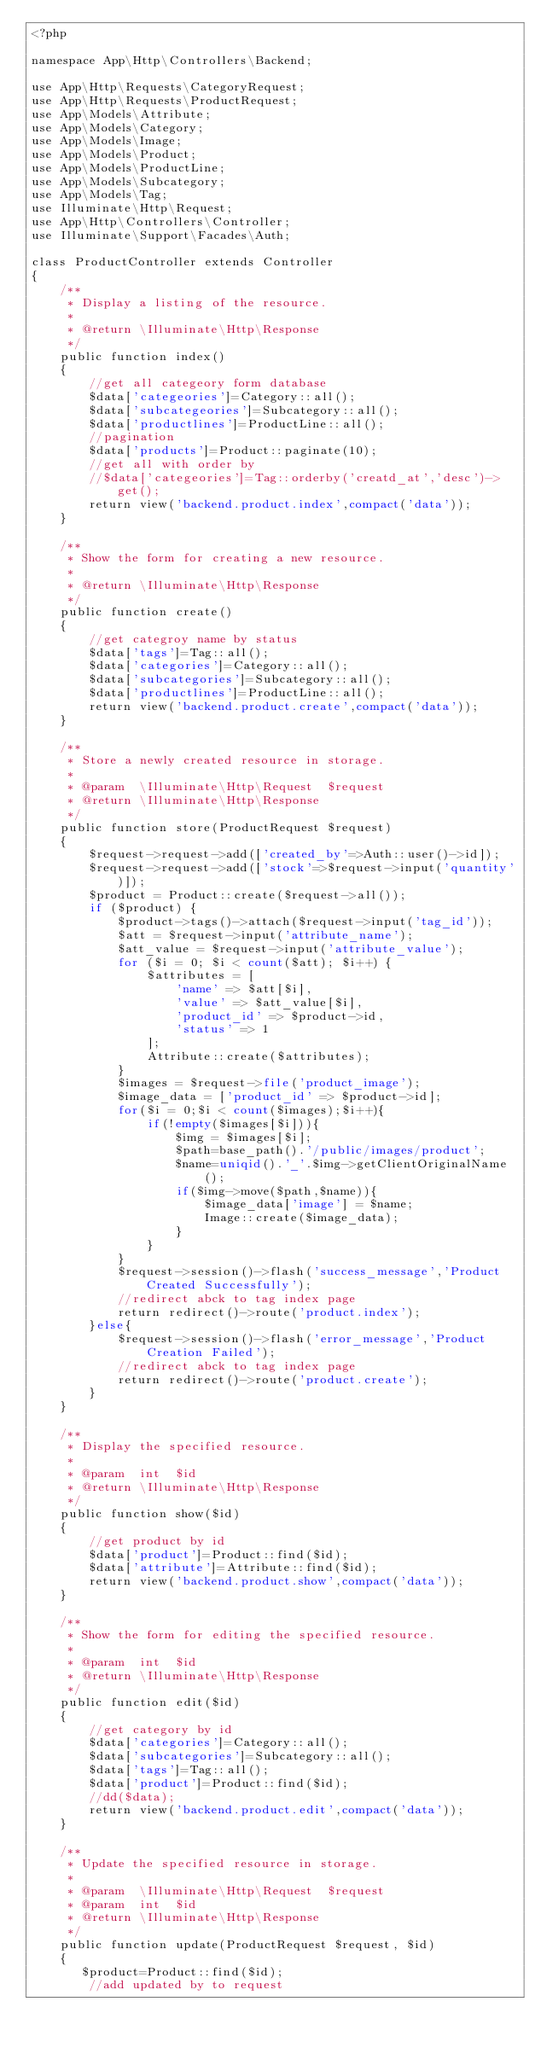Convert code to text. <code><loc_0><loc_0><loc_500><loc_500><_PHP_><?php

namespace App\Http\Controllers\Backend;

use App\Http\Requests\CategoryRequest;
use App\Http\Requests\ProductRequest;
use App\Models\Attribute;
use App\Models\Category;
use App\Models\Image;
use App\Models\Product;
use App\Models\ProductLine;
use App\Models\Subcategory;
use App\Models\Tag;
use Illuminate\Http\Request;
use App\Http\Controllers\Controller;
use Illuminate\Support\Facades\Auth;

class ProductController extends Controller
{
    /**
     * Display a listing of the resource.
     *
     * @return \Illuminate\Http\Response
     */
    public function index()
    {
        //get all categeory form database
        $data['categeories']=Category::all();
        $data['subcategeories']=Subcategory::all();
        $data['productlines']=ProductLine::all();
        //pagination
        $data['products']=Product::paginate(10);
        //get all with order by
        //$data['categeories']=Tag::orderby('creatd_at','desc')->get();
        return view('backend.product.index',compact('data'));
    }

    /**
     * Show the form for creating a new resource.
     *
     * @return \Illuminate\Http\Response
     */
    public function create()
    {
        //get categroy name by status
        $data['tags']=Tag::all();
        $data['categories']=Category::all();
        $data['subcategories']=Subcategory::all();
        $data['productlines']=ProductLine::all();
        return view('backend.product.create',compact('data'));
    }

    /**
     * Store a newly created resource in storage.
     *
     * @param  \Illuminate\Http\Request  $request
     * @return \Illuminate\Http\Response
     */
    public function store(ProductRequest $request)
    {
        $request->request->add(['created_by'=>Auth::user()->id]);
        $request->request->add(['stock'=>$request->input('quantity')]);
        $product = Product::create($request->all());
        if ($product) {
            $product->tags()->attach($request->input('tag_id'));
            $att = $request->input('attribute_name');
            $att_value = $request->input('attribute_value');
            for ($i = 0; $i < count($att); $i++) {
                $attributes = [
                    'name' => $att[$i],
                    'value' => $att_value[$i],
                    'product_id' => $product->id,
                    'status' => 1
                ];
                Attribute::create($attributes);
            }
            $images = $request->file('product_image');
            $image_data = ['product_id' => $product->id];
            for($i = 0;$i < count($images);$i++){
                if(!empty($images[$i])){
                    $img = $images[$i];
                    $path=base_path().'/public/images/product';
                    $name=uniqid().'_'.$img->getClientOriginalName();
                    if($img->move($path,$name)){
                        $image_data['image'] = $name;
                        Image::create($image_data);
                    }
                }
            }
            $request->session()->flash('success_message','Product Created Successfully');
            //redirect abck to tag index page
            return redirect()->route('product.index');
        }else{
            $request->session()->flash('error_message','Product Creation Failed');
            //redirect abck to tag index page
            return redirect()->route('product.create');
        }
    }

    /**
     * Display the specified resource.
     *
     * @param  int  $id
     * @return \Illuminate\Http\Response
     */
    public function show($id)
    {
        //get product by id
        $data['product']=Product::find($id);
        $data['attribute']=Attribute::find($id);
        return view('backend.product.show',compact('data'));
    }

    /**
     * Show the form for editing the specified resource.
     *
     * @param  int  $id
     * @return \Illuminate\Http\Response
     */
    public function edit($id)
    {
        //get category by id
        $data['categories']=Category::all();
        $data['subcategories']=Subcategory::all();
        $data['tags']=Tag::all();
        $data['product']=Product::find($id);
        //dd($data);
        return view('backend.product.edit',compact('data'));
    }

    /**
     * Update the specified resource in storage.
     *
     * @param  \Illuminate\Http\Request  $request
     * @param  int  $id
     * @return \Illuminate\Http\Response
     */
    public function update(ProductRequest $request, $id)
    {
       $product=Product::find($id);
        //add updated by to request</code> 